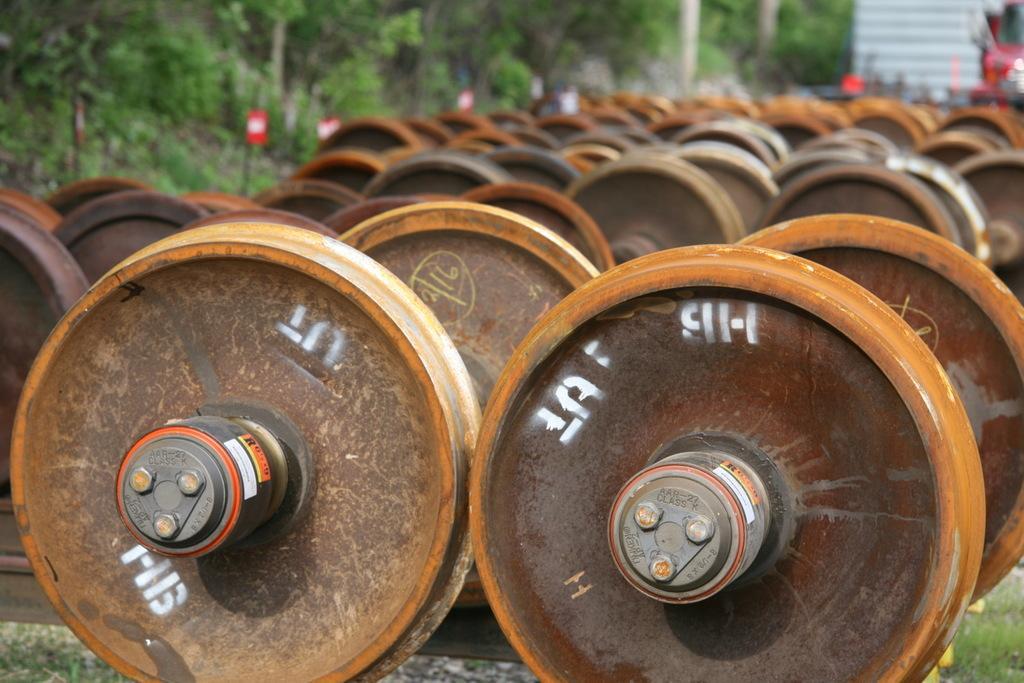How would you summarize this image in a sentence or two? In this image we can see train wheels placed on the ground and trees. 